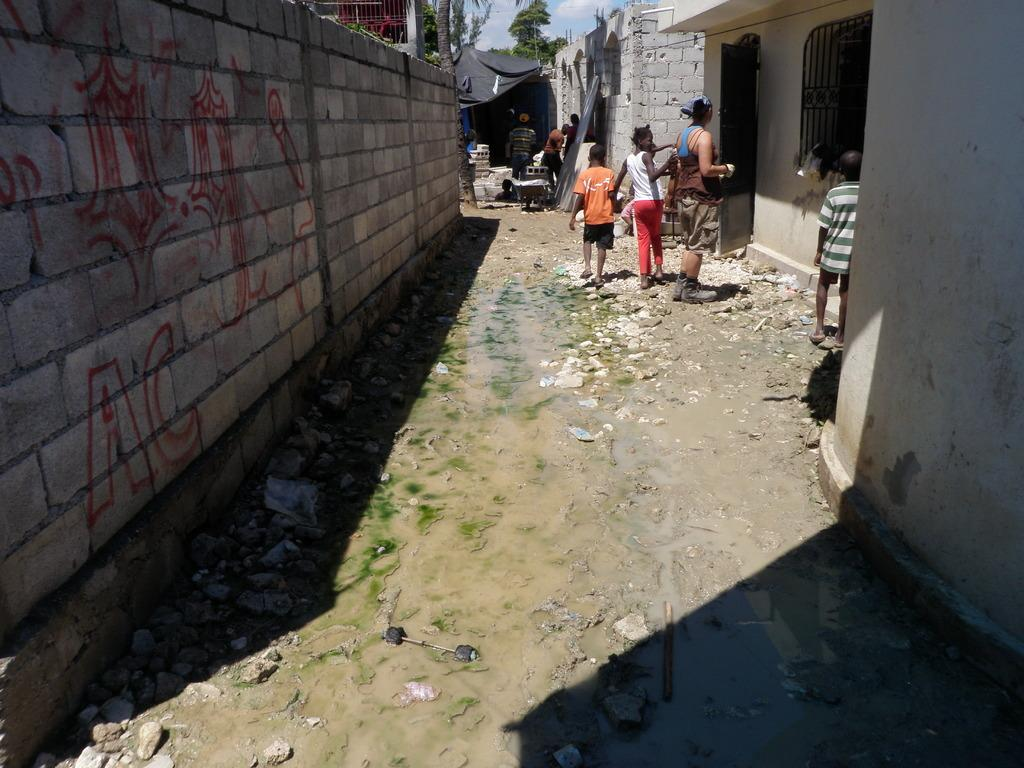What are the people in the image doing? The people in the image are walking. On what surface are the people walking? The people are walking on the ground. What type of structure can be seen in the image? There is a compound wall and a building visible in the image. What type of vegetation is present in the image? There is a tree visible in the image. Can you see any children playing on the playground in the image? There is no playground present in the image. What color is the harmony of the tree in the image? The concept of "harmony" does not apply to the color of the tree, as it is not a musical term. The tree in the image is likely green, but the exact color cannot be determined without more information. 